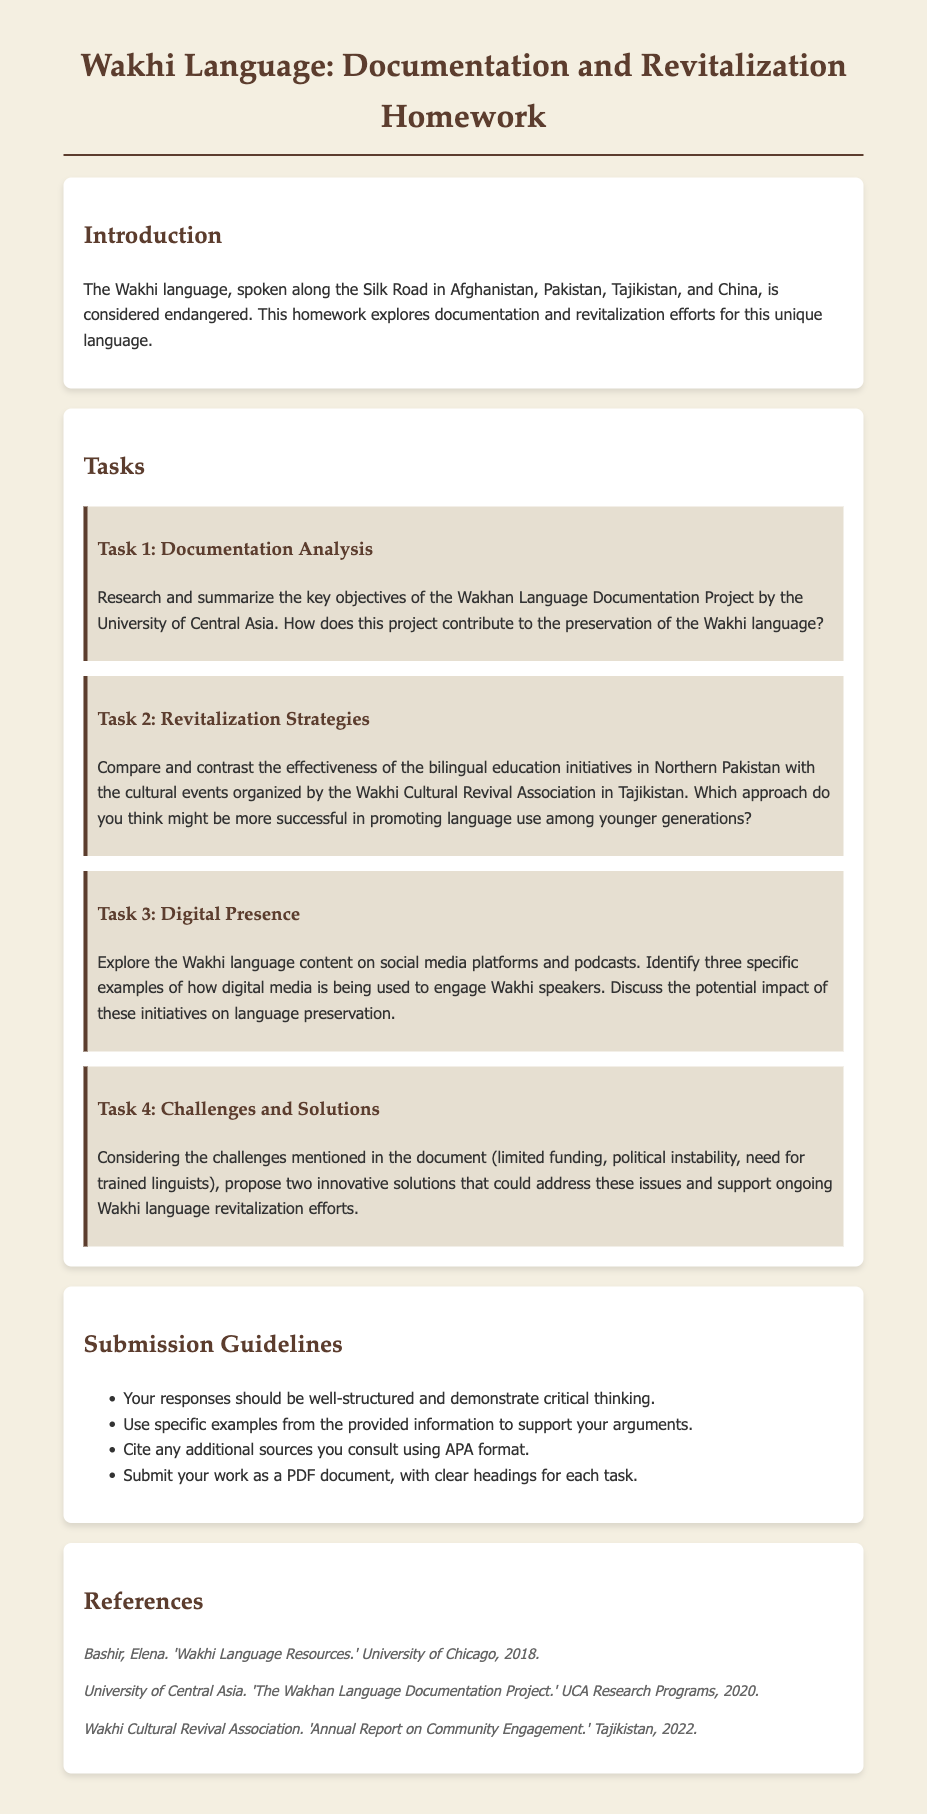What is the title of the homework document? The title of the homework document is found at the top of the page, indicating its main theme.
Answer: Wakhi Language: Documentation and Revitalization Homework Which organization is behind the Wakhan Language Documentation Project? The document mentions the institution responsible for the documentation efforts in relation to the Wakhi language.
Answer: University of Central Asia What are the two revitalization initiatives mentioned in the document? The document lists specific initiatives aimed at revitalizing the Wakhi language.
Answer: Bilingual education initiatives and cultural events How many tasks are outlined in the homework? The total number of tasks is given in a numbered format in the section on tasks.
Answer: Four What year was the report by the Wakhi Cultural Revival Association published? The document provides the publication year for the annual report from the mentioned association.
Answer: 2022 What is one challenge mentioned in the document regarding Wakhi language revitalization? The document discusses various issues related to the preservation and revitalization of the language.
Answer: Limited funding What format should the submitted work be in? The document specifies the acceptable format for submission in the guidelines section.
Answer: PDF document Which social media platform is referenced in connection with the Wakhi language? The homework asks about examples of digital media engagement, which includes specific types of platforms.
Answer: Social media platforms What should the responses demonstrate according to the submission guidelines? The guidelines indicate a certain quality that the answers should exhibit.
Answer: Critical thinking 